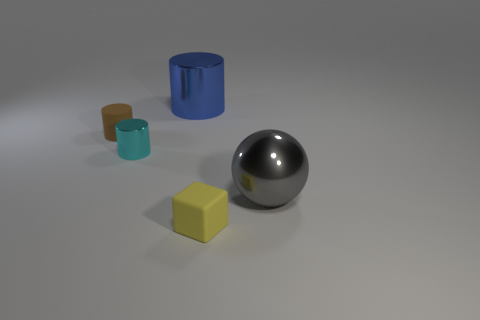Can you explain the significance of color in this composition? Color plays an important role in distinguishing between objects and highlighting their forms. In this composition, the varied colors—vibrant blue, muted teal, subdued brown, and bright yellow—help to differentiate the objects and add visual interest. The differences in hue and saturation also contribute to the perception of depth and texture, making the more saturated objects, like the blue cylinder, appear closer or more in focus than the others. 